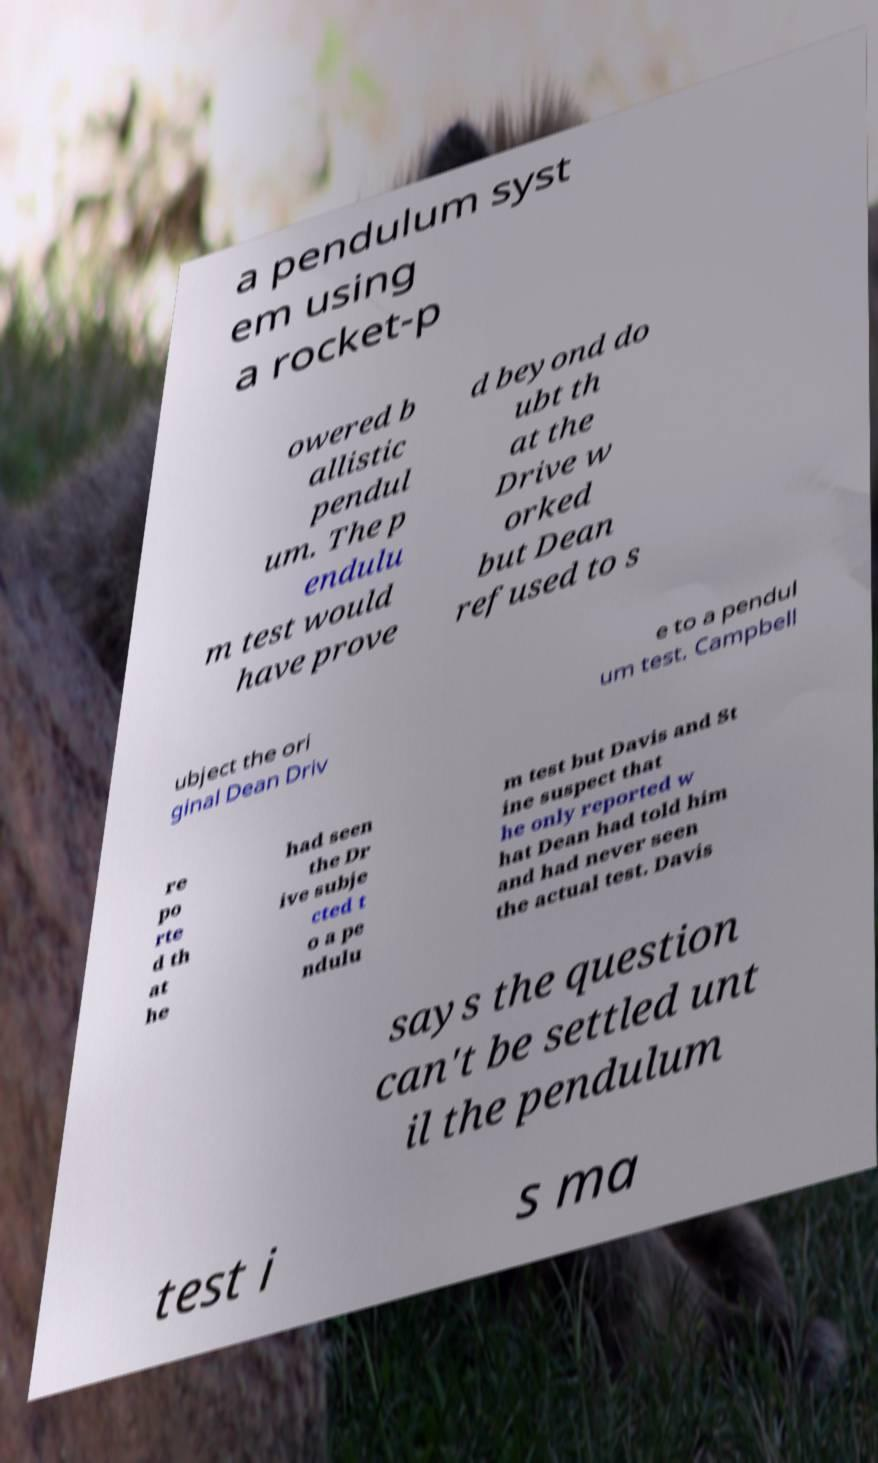Can you read and provide the text displayed in the image?This photo seems to have some interesting text. Can you extract and type it out for me? a pendulum syst em using a rocket-p owered b allistic pendul um. The p endulu m test would have prove d beyond do ubt th at the Drive w orked but Dean refused to s ubject the ori ginal Dean Driv e to a pendul um test. Campbell re po rte d th at he had seen the Dr ive subje cted t o a pe ndulu m test but Davis and St ine suspect that he only reported w hat Dean had told him and had never seen the actual test. Davis says the question can't be settled unt il the pendulum test i s ma 